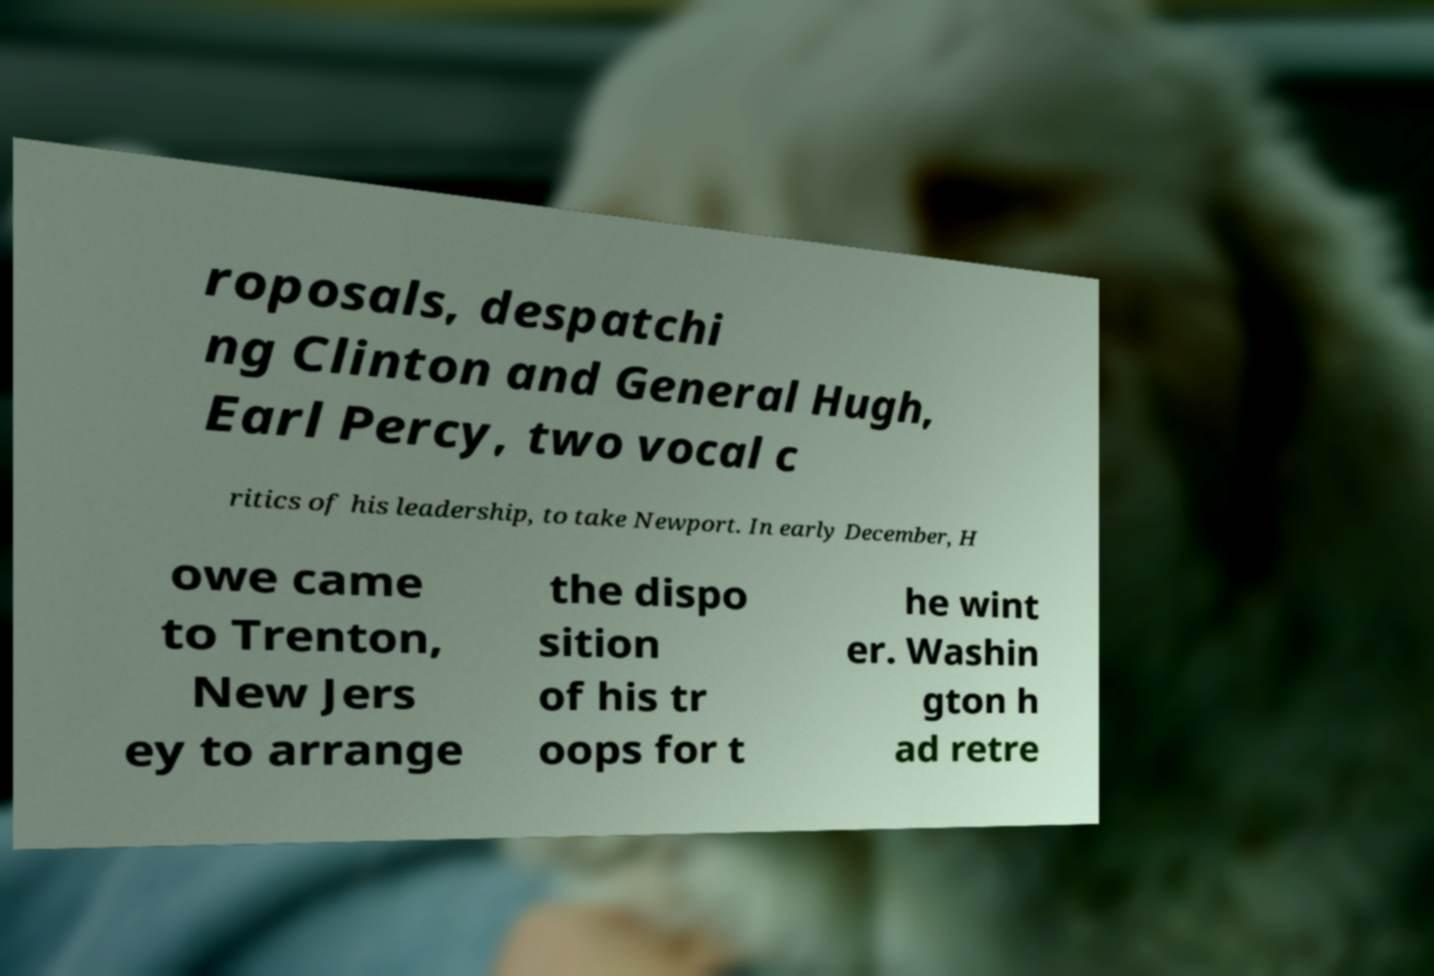For documentation purposes, I need the text within this image transcribed. Could you provide that? roposals, despatchi ng Clinton and General Hugh, Earl Percy, two vocal c ritics of his leadership, to take Newport. In early December, H owe came to Trenton, New Jers ey to arrange the dispo sition of his tr oops for t he wint er. Washin gton h ad retre 